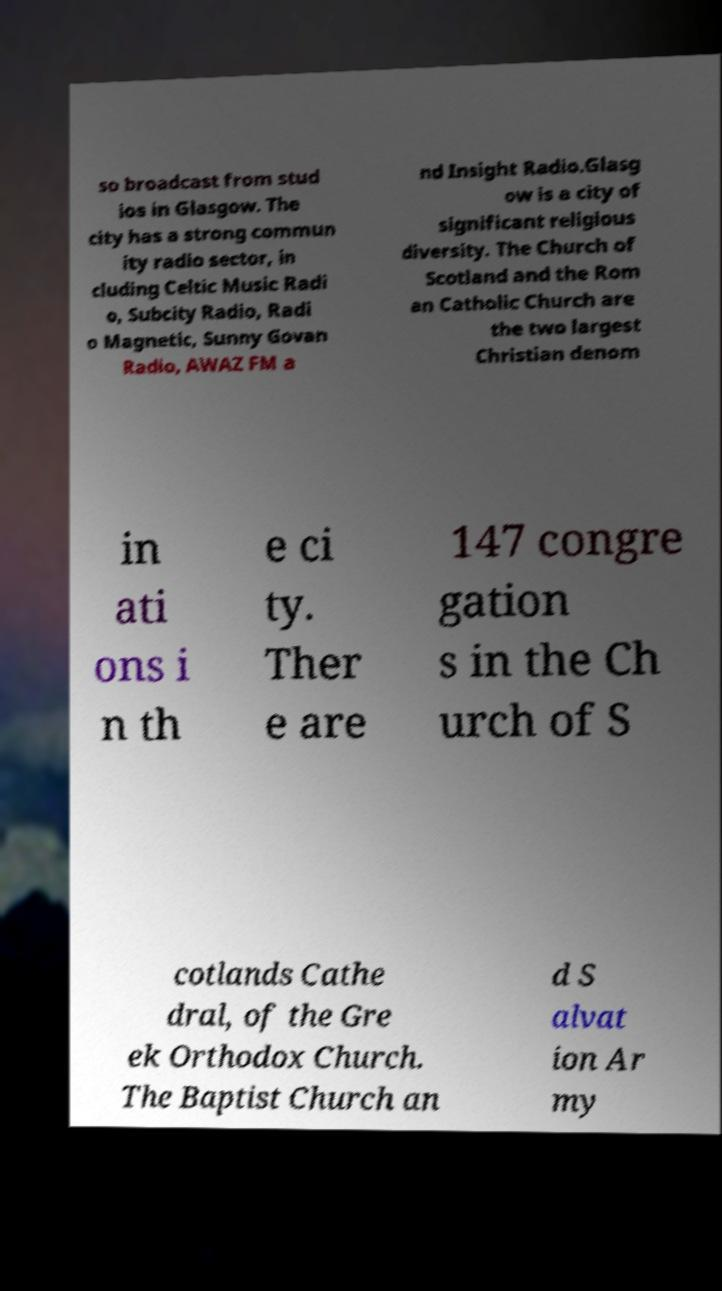Could you assist in decoding the text presented in this image and type it out clearly? so broadcast from stud ios in Glasgow. The city has a strong commun ity radio sector, in cluding Celtic Music Radi o, Subcity Radio, Radi o Magnetic, Sunny Govan Radio, AWAZ FM a nd Insight Radio.Glasg ow is a city of significant religious diversity. The Church of Scotland and the Rom an Catholic Church are the two largest Christian denom in ati ons i n th e ci ty. Ther e are 147 congre gation s in the Ch urch of S cotlands Cathe dral, of the Gre ek Orthodox Church. The Baptist Church an d S alvat ion Ar my 